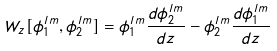<formula> <loc_0><loc_0><loc_500><loc_500>W _ { z } [ \phi ^ { l m } _ { 1 } , \phi ^ { l m } _ { 2 } ] = \phi ^ { l m } _ { 1 } \frac { d \phi ^ { l m } _ { 2 } } { d z } - \phi ^ { l m } _ { 2 } \frac { d \phi ^ { l m } _ { 1 } } { d z }</formula> 